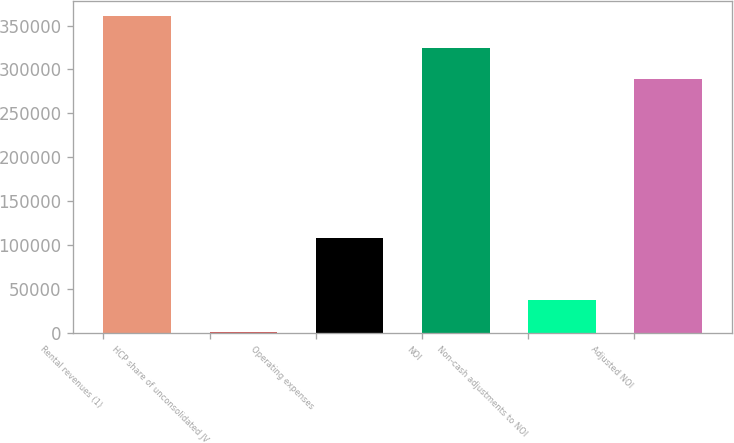Convert chart. <chart><loc_0><loc_0><loc_500><loc_500><bar_chart><fcel>Rental revenues (1)<fcel>HCP share of unconsolidated JV<fcel>Operating expenses<fcel>NOI<fcel>Non-cash adjustments to NOI<fcel>Adjusted NOI<nl><fcel>360441<fcel>1601<fcel>108682<fcel>324748<fcel>37294.6<fcel>289054<nl></chart> 